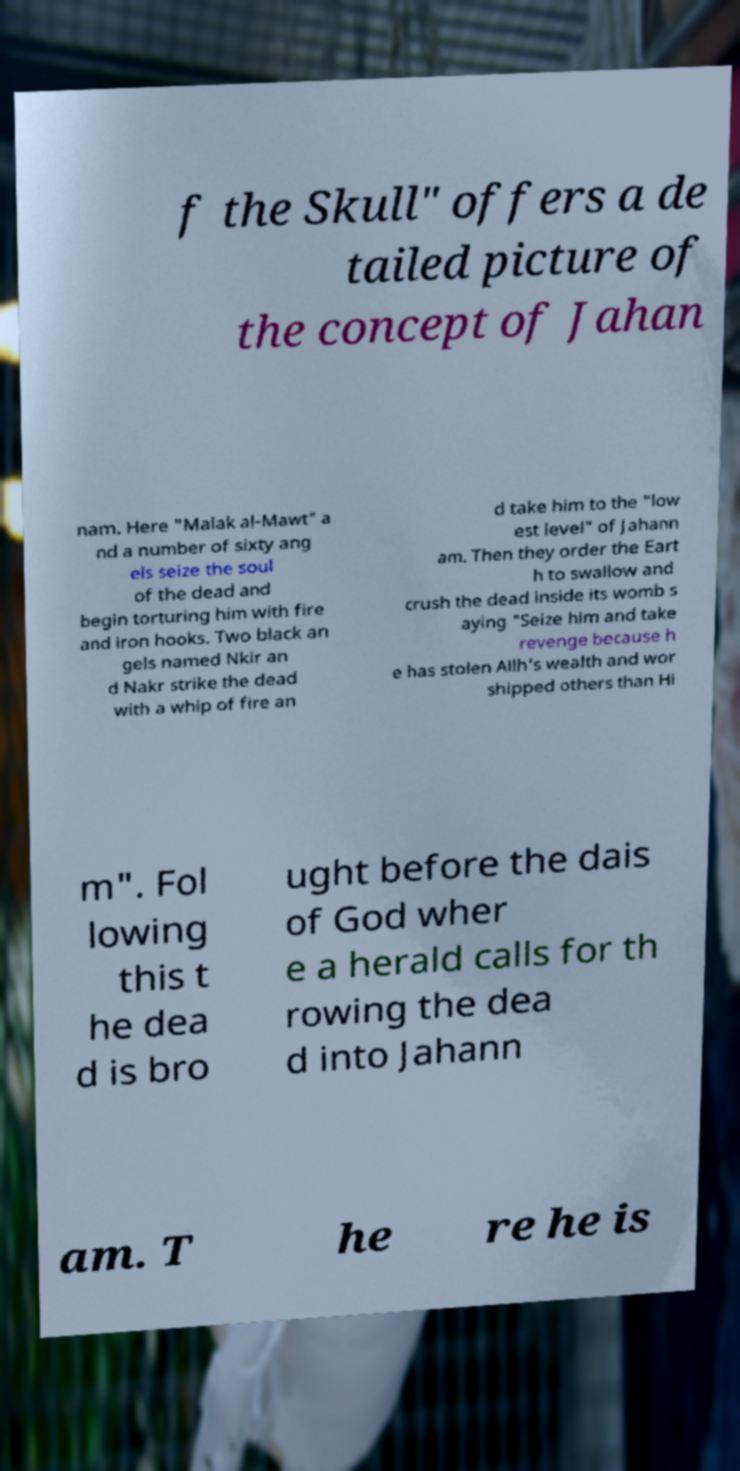Could you extract and type out the text from this image? f the Skull" offers a de tailed picture of the concept of Jahan nam. Here "Malak al-Mawt" a nd a number of sixty ang els seize the soul of the dead and begin torturing him with fire and iron hooks. Two black an gels named Nkir an d Nakr strike the dead with a whip of fire an d take him to the "low est level" of Jahann am. Then they order the Eart h to swallow and crush the dead inside its womb s aying "Seize him and take revenge because h e has stolen Allh's wealth and wor shipped others than Hi m". Fol lowing this t he dea d is bro ught before the dais of God wher e a herald calls for th rowing the dea d into Jahann am. T he re he is 